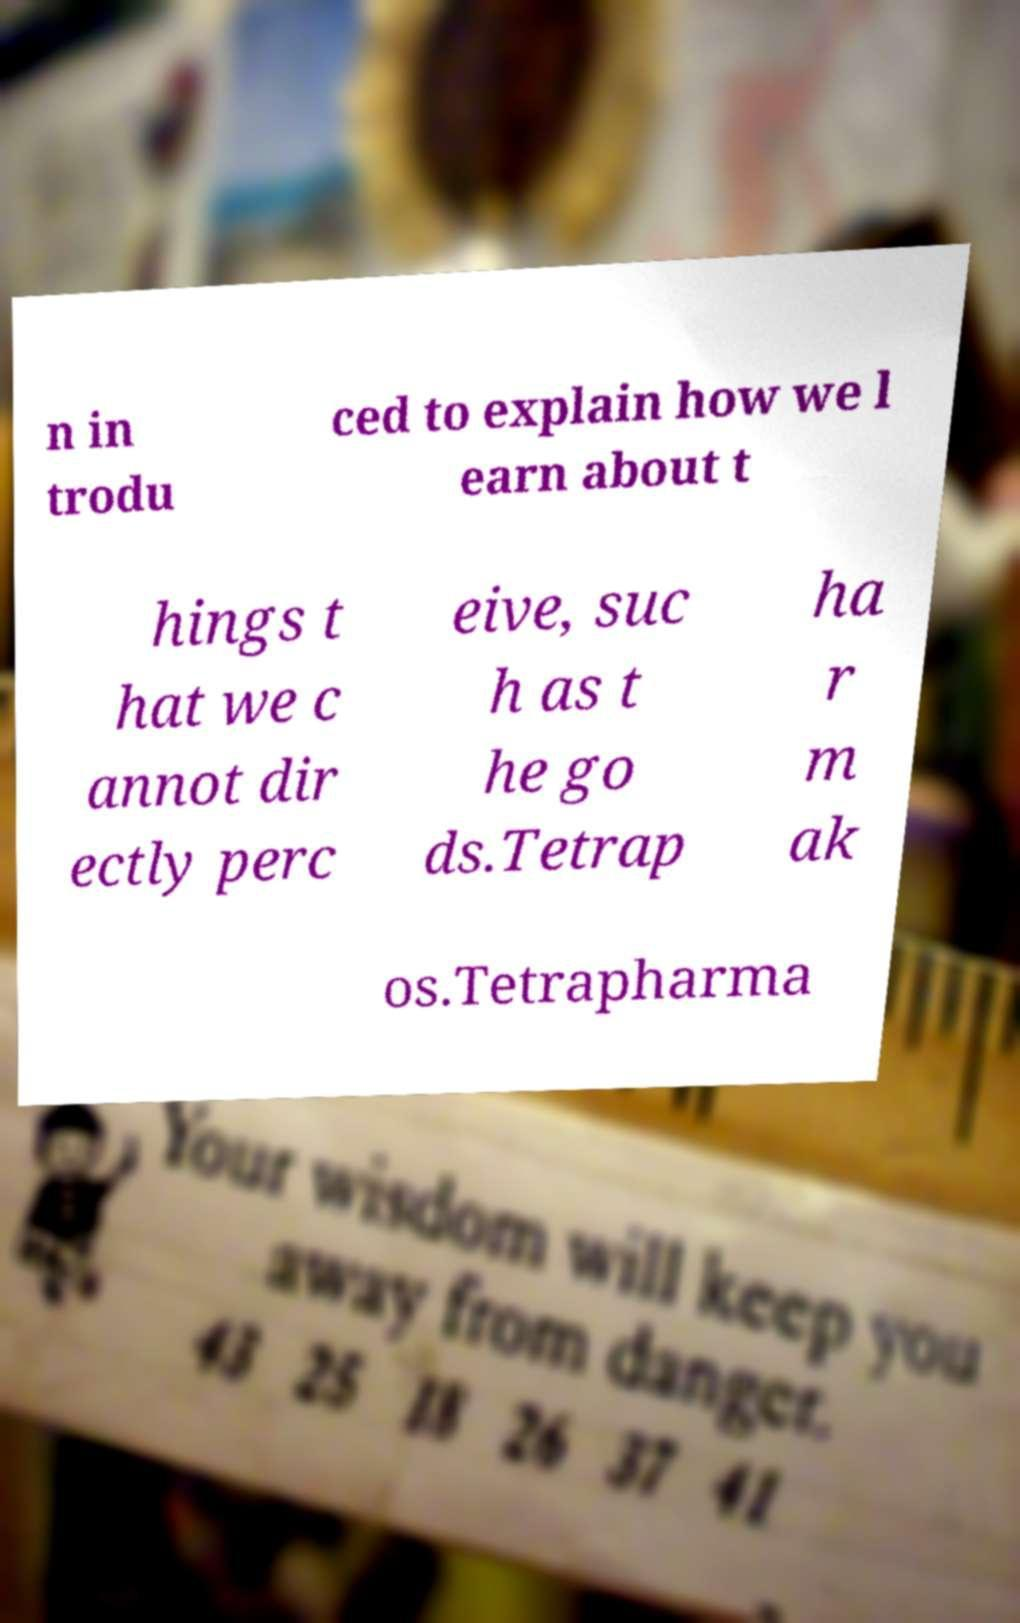I need the written content from this picture converted into text. Can you do that? n in trodu ced to explain how we l earn about t hings t hat we c annot dir ectly perc eive, suc h as t he go ds.Tetrap ha r m ak os.Tetrapharma 